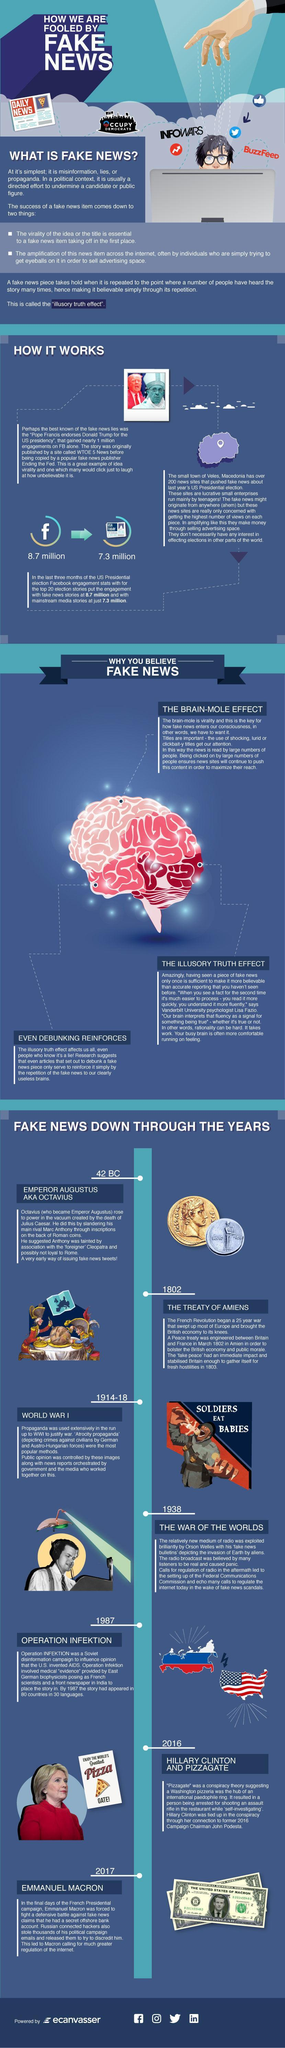How many flags are in this infographic?
Answer the question with a short phrase. 2 How many coins are in this infographic? 2 